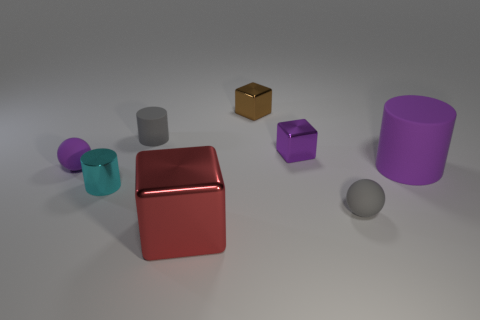Is there any other thing that has the same size as the red metal object?
Offer a terse response. Yes. What number of small objects are matte balls or shiny things?
Offer a very short reply. 5. Is the number of big cylinders less than the number of red cylinders?
Offer a terse response. No. What is the color of the other tiny metallic thing that is the same shape as the tiny brown metal object?
Keep it short and to the point. Purple. Are there any other things that are the same shape as the tiny purple metallic thing?
Your answer should be very brief. Yes. Are there more purple cubes than big cyan balls?
Your answer should be compact. Yes. How many other objects are there of the same material as the small purple cube?
Give a very brief answer. 3. The purple rubber thing that is to the left of the small cylinder behind the cylinder on the right side of the large metallic thing is what shape?
Offer a terse response. Sphere. Are there fewer tiny gray things that are on the right side of the large purple rubber object than tiny cylinders behind the cyan metallic cylinder?
Offer a terse response. Yes. Is there a large matte object that has the same color as the metallic cylinder?
Make the answer very short. No. 